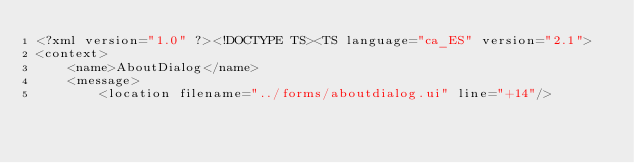Convert code to text. <code><loc_0><loc_0><loc_500><loc_500><_TypeScript_><?xml version="1.0" ?><!DOCTYPE TS><TS language="ca_ES" version="2.1">
<context>
    <name>AboutDialog</name>
    <message>
        <location filename="../forms/aboutdialog.ui" line="+14"/></code> 